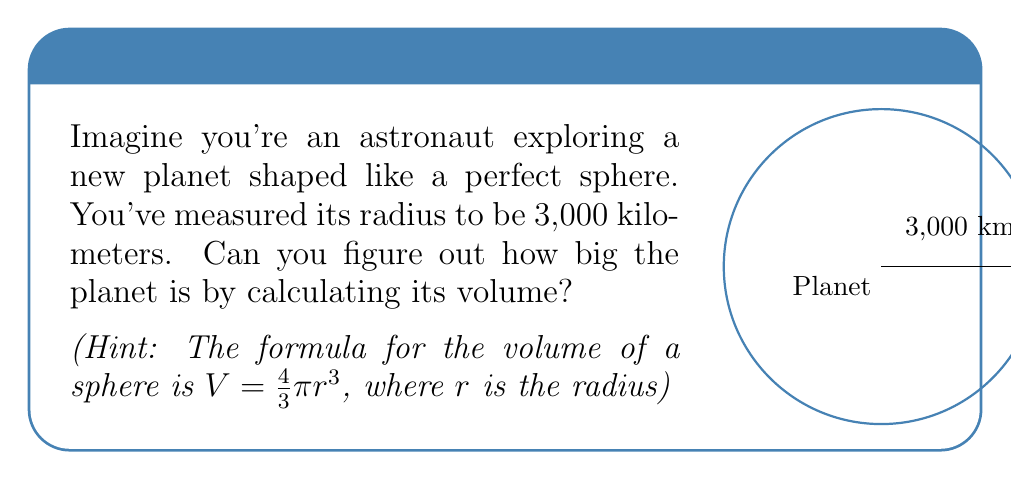What is the answer to this math problem? Let's break this down step-by-step:

1. We know the radius of the planet is 3,000 kilometers.
2. The formula for the volume of a sphere is $V = \frac{4}{3}\pi r^3$.
3. Let's plug in our radius:
   $V = \frac{4}{3}\pi (3000)^3$
4. First, let's calculate $(3000)^3$:
   $3000 \times 3000 \times 3000 = 27,000,000,000$
5. Now our equation looks like this:
   $V = \frac{4}{3}\pi \times 27,000,000,000$
6. Let's multiply $\frac{4}{3}$ by 27,000,000,000:
   $\frac{4}{3} \times 27,000,000,000 = 36,000,000,000$
7. So now we have:
   $V = 36,000,000,000\pi$
8. $\pi$ is approximately 3.14159, so let's multiply:
   $V \approx 36,000,000,000 \times 3.14159 = 113,097,240,000$

Therefore, the volume of the planet is approximately 113,097,240,000 cubic kilometers.
Answer: $113,097,240,000$ cubic kilometers 